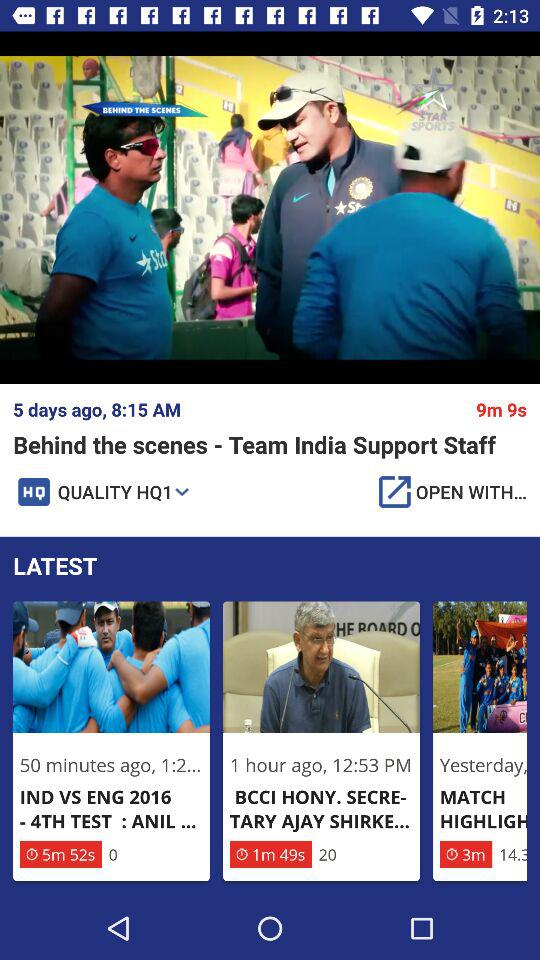How long is the video of "BCCI HONY. SECRETARY AJAY SHIRKE..."? The length of the video is 1 minute 49 seconds. 